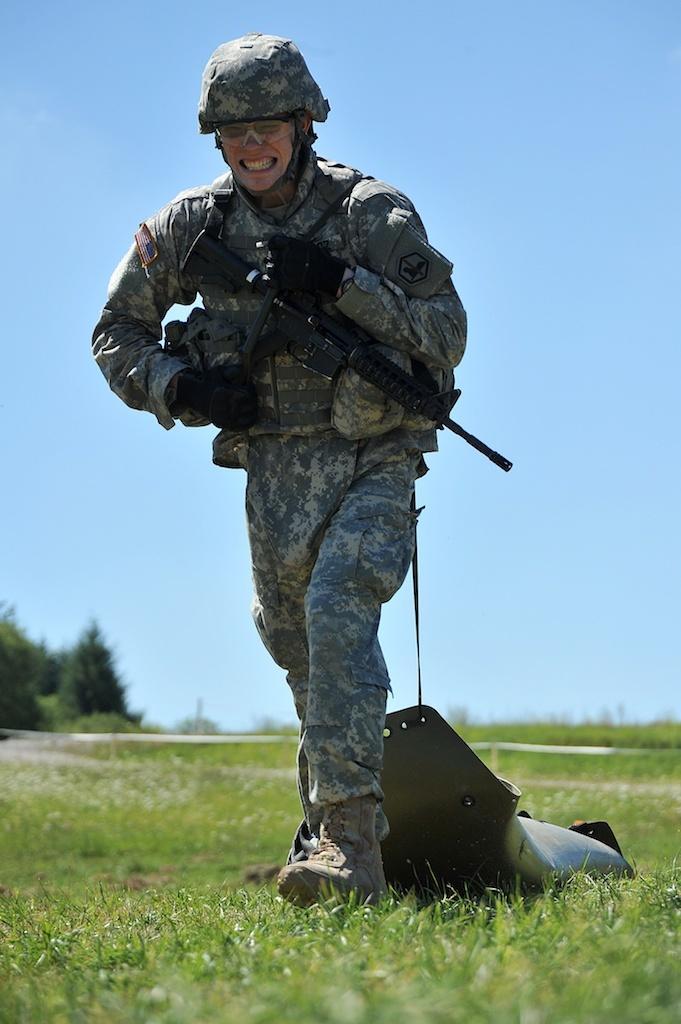Describe this image in one or two sentences. In the center of the image we can see a man wearing the military uniform and also the glasses and holding the gun and pulling the object which is on the grass. In the background we can see the trees and also the sky. 